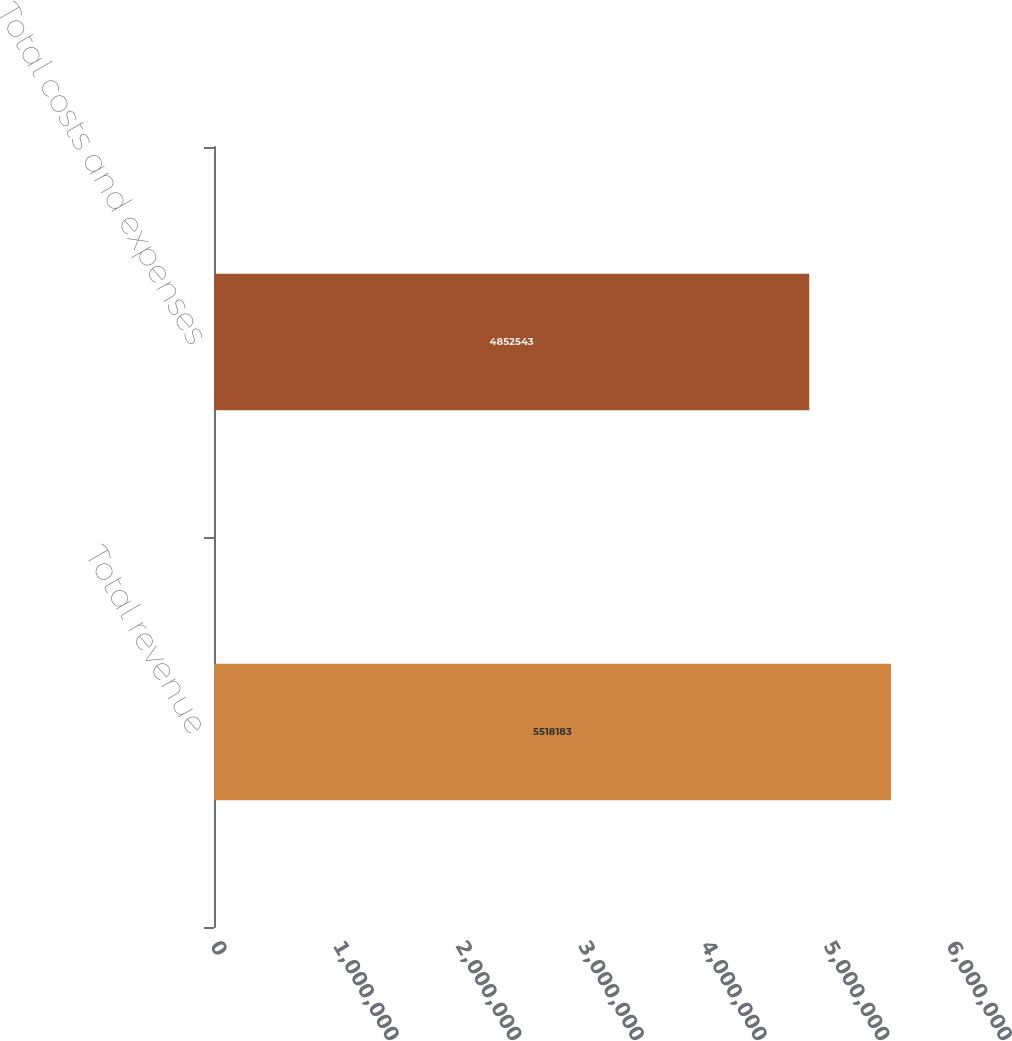Convert chart to OTSL. <chart><loc_0><loc_0><loc_500><loc_500><bar_chart><fcel>Total revenue<fcel>Total costs and expenses<nl><fcel>5.51818e+06<fcel>4.85254e+06<nl></chart> 